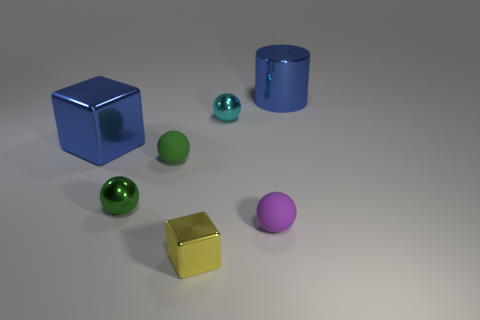Subtract 1 spheres. How many spheres are left? 3 Add 2 blue shiny cylinders. How many objects exist? 9 Subtract all cylinders. How many objects are left? 6 Add 2 tiny metallic blocks. How many tiny metallic blocks are left? 3 Add 5 red cubes. How many red cubes exist? 5 Subtract 0 green blocks. How many objects are left? 7 Subtract all large blue metallic things. Subtract all tiny purple spheres. How many objects are left? 4 